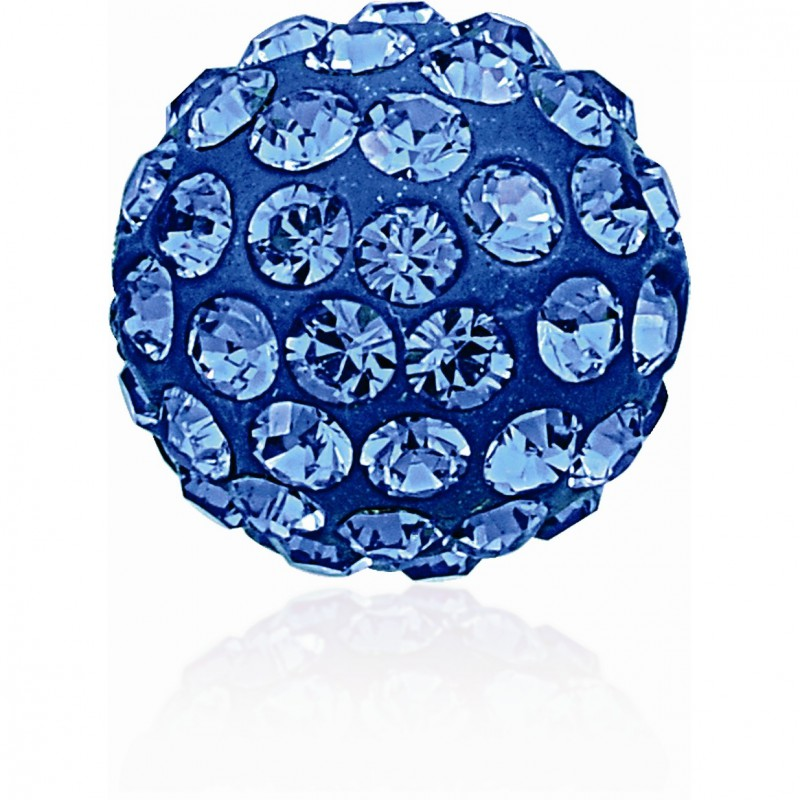Imagine these gemstones were discovered in an ancient treasure chest. What might the story behind that be? Imagine a group of archaeologists uncovering an ancient shipwreck deep below the ocean’s surface. Amongst the remains of the ship, they discover a heavy, old treasure chest, encrusted with barnacles and seaweed. Upon opening the chest, they find it filled with a collection of exquisite jewelry and artifacts, all adorned with these dazzling blue gemstones. The gemstones shimmer under the light of their torches, suggesting they have been meticulously preserved through the centuries. The story behind the treasure could be one of a wealthy merchant who, while on a voyage to trade in far-off lands, fell victim to a fierce storm. The ship, laden with his precious cargo of gems and treasures, sank to the ocean floor, where it lay undisturbed for generations until its serendipitous discovery. Each gemstone piece could have a history of its own, perhaps once owned by royalty or crafted by a legendary artisan, making the find not just a treasure trove of gemstones but a collection of priceless pieces of history. Create a quirky story about these gemstones. Several centuries ago, in a whimsical kingdom known for its eccentric inhabitants and peculiar customs, there was a legend about a mischievous dragon named Azul. Azul wasn’t like other dragons; instead of hoarding gold, he had a penchant for collecting blue gemstones. He would secretly sneak into human settlements and 'borrow' any blue gems he could find, always returning them slightly polished and more splendid than before. The villagers didn’t mind much, as they always got their gems back more beautiful than before. One day, Azul decided to create a giant, glittering mosaic on the walls of his cave using the treasures he had gathered. This mosaic depicted his adventures and whimsical exploits, each section more dazzling than the next. Villagers started visiting Azul’s cave to admire his artwork, and it became a renowned attraction. The dragon even added little gems here and there while sharing tales of his escapades, creating a unique, interactive experience. The kingdom celebrated Azul’s quirky nature and his artistic contributions, blending dragon lore with artistic flair, making it a place where creativity and whimsy were cherished above all. 